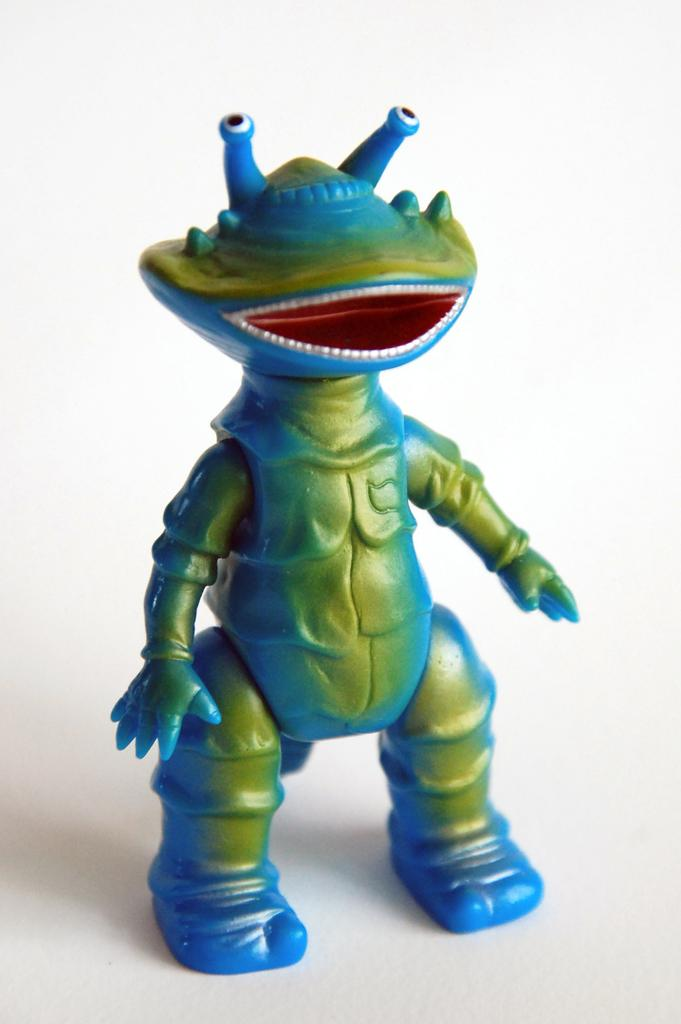What object can be seen in the image? There is a toy in the image. What color is the background of the image? The background of the image is white. What type of request can be seen written on the toy in the image? There is no request visible on the toy in the image. What shape is the pipe that is connected to the toy in the image? There is no pipe connected to the toy in the image. 